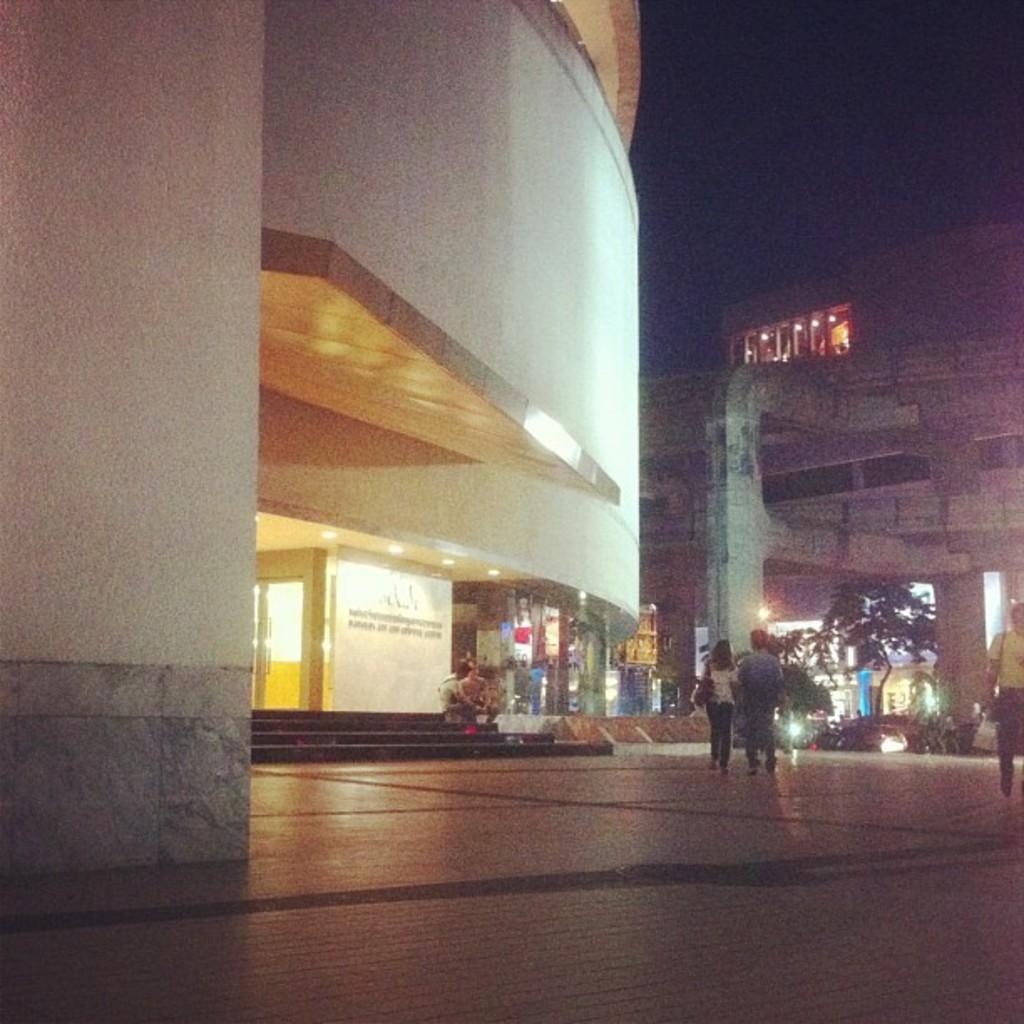Describe this image in one or two sentences. In this image I can see few people where one is sitting and rest all are standing. I can also see few buildings, number of lights, few trees and in the centre of the image I can see something is written on the building's wall. 